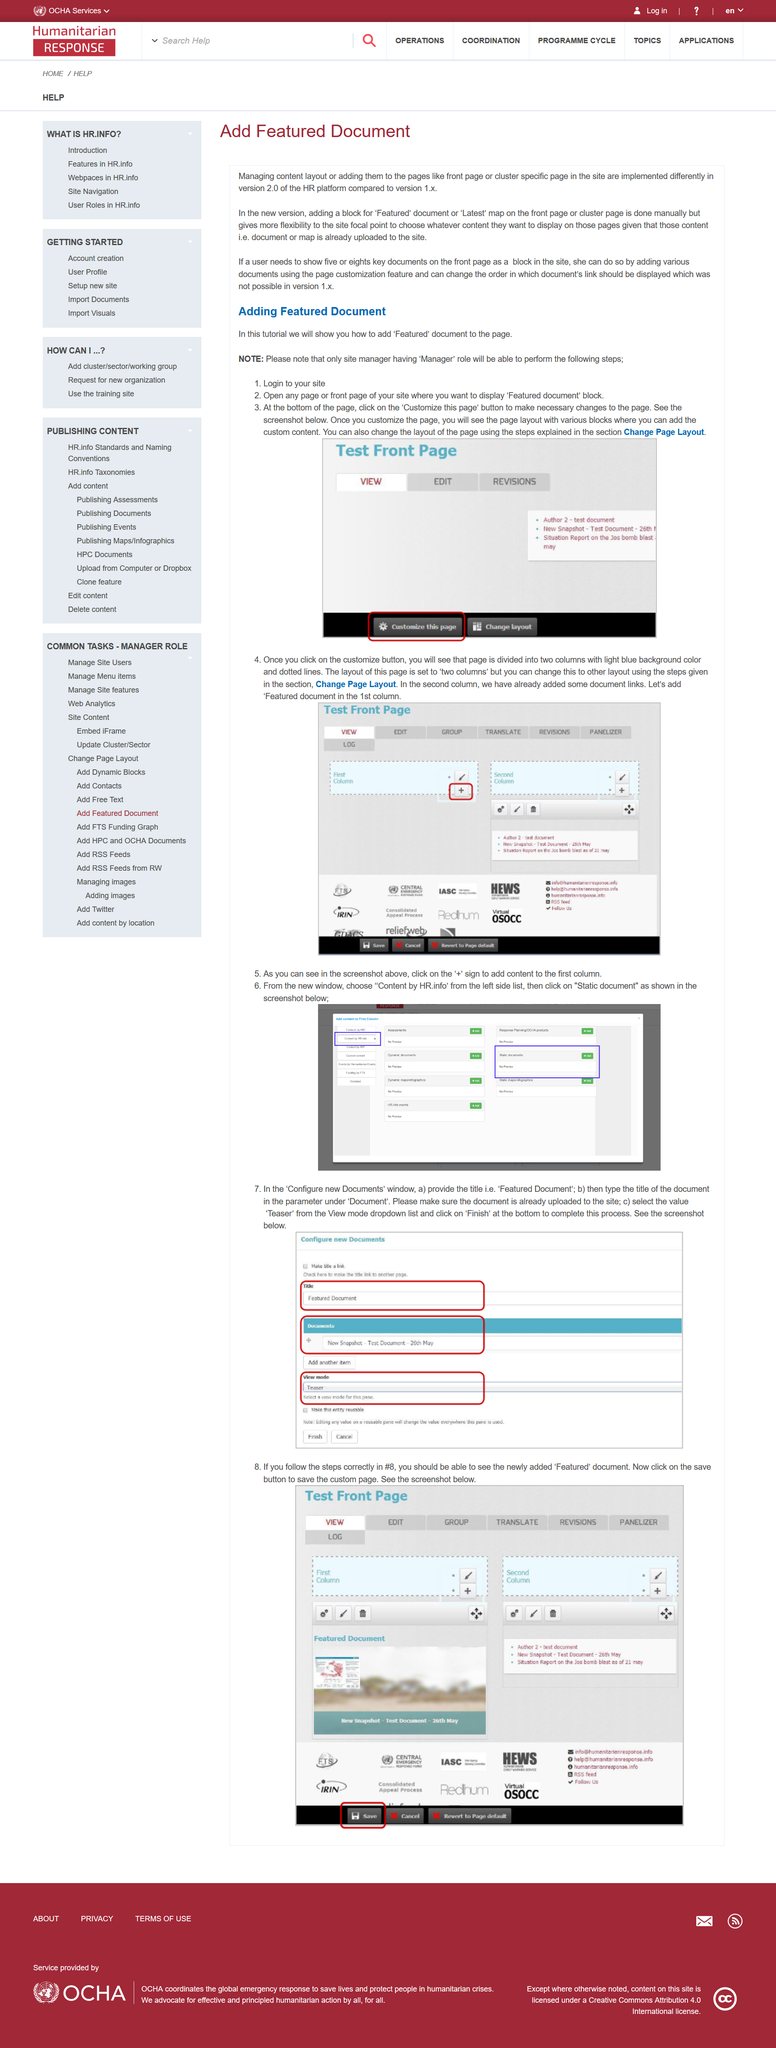List a handful of essential elements in this visual. To make changes to the page, click on the "Customize this page" button that allows you to do so. The page customization feature enables the addition of various documents. The user has the ability to modify the display order of document links in a document. The steps outlined in the article can only be performed by the site manager who holds the 'Manager' role. The main objective of this tutorial is to demonstrate how to include a "Featured" document on the page. 